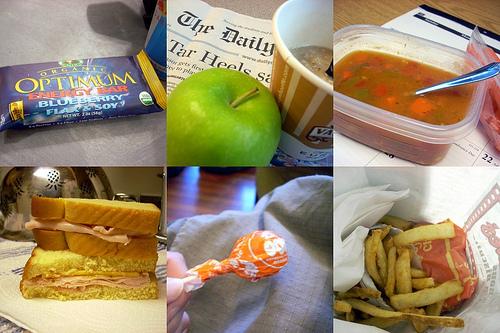Is this a healthy meal?
Be succinct. No. What is the 5th picture of?
Keep it brief. Sucker. How many fruits are in the images?
Concise answer only. 1. 